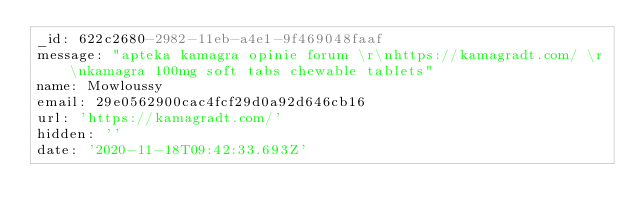Convert code to text. <code><loc_0><loc_0><loc_500><loc_500><_YAML_>_id: 622c2680-2982-11eb-a4e1-9f469048faaf
message: "apteka kamagra opinie forum \r\nhttps://kamagradt.com/ \r\nkamagra 100mg soft tabs chewable tablets"
name: Mowloussy
email: 29e0562900cac4fcf29d0a92d646cb16
url: 'https://kamagradt.com/'
hidden: ''
date: '2020-11-18T09:42:33.693Z'
</code> 